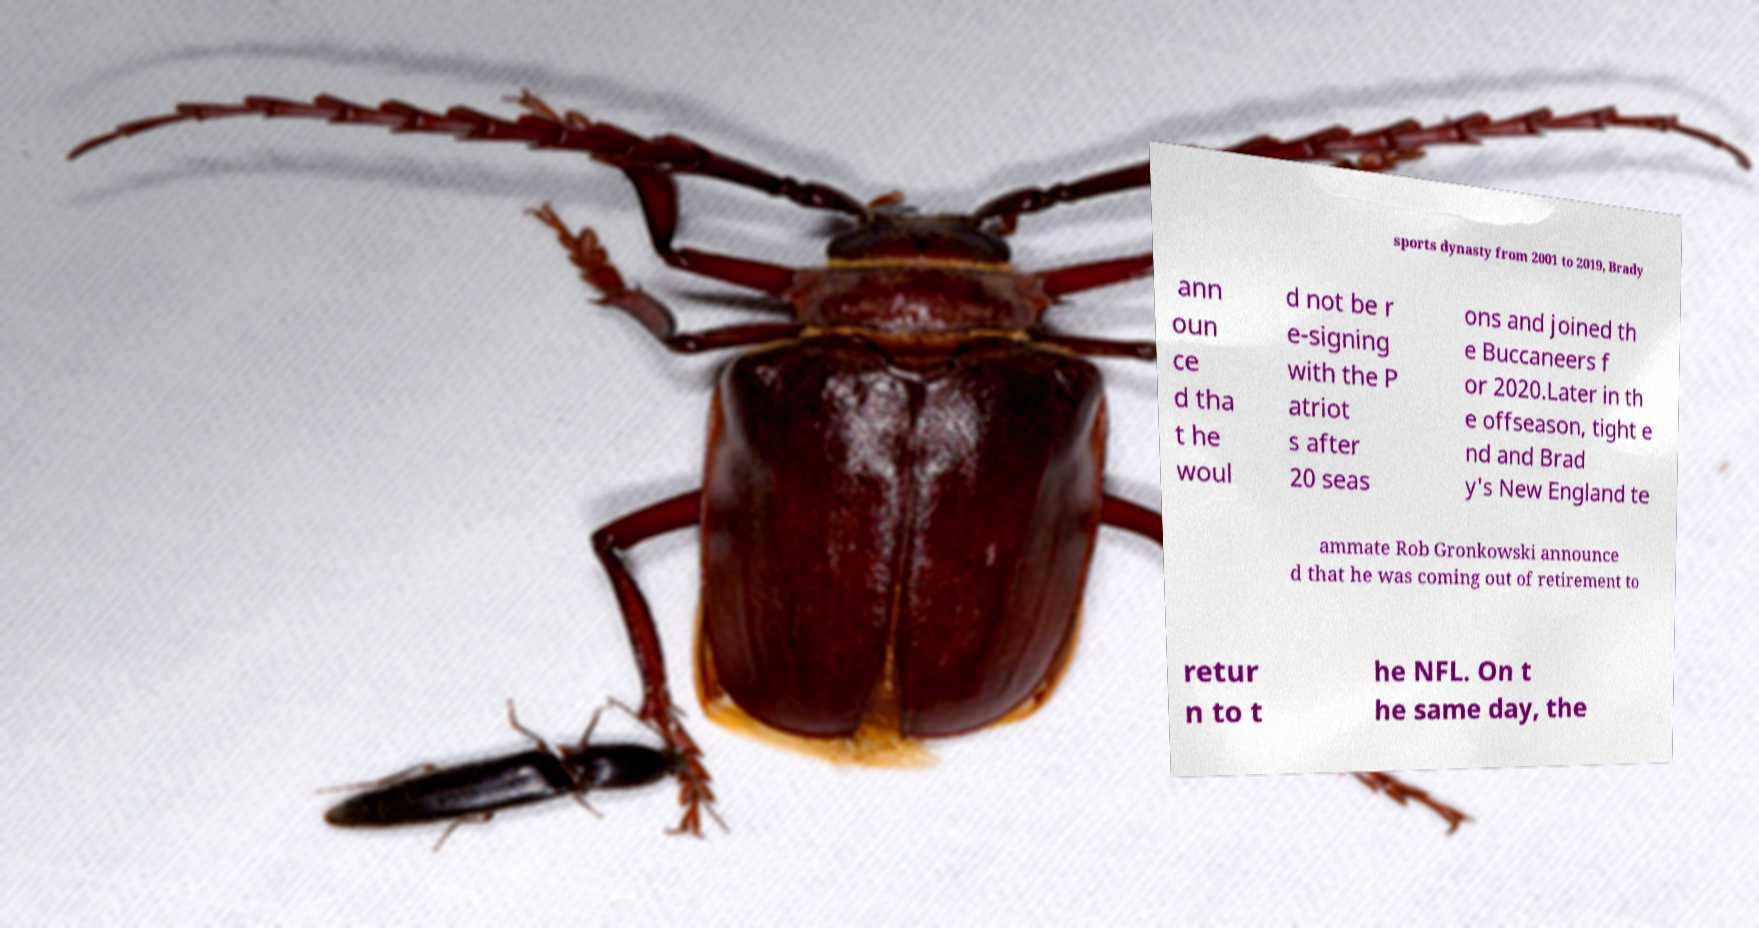Could you extract and type out the text from this image? sports dynasty from 2001 to 2019, Brady ann oun ce d tha t he woul d not be r e-signing with the P atriot s after 20 seas ons and joined th e Buccaneers f or 2020.Later in th e offseason, tight e nd and Brad y's New England te ammate Rob Gronkowski announce d that he was coming out of retirement to retur n to t he NFL. On t he same day, the 